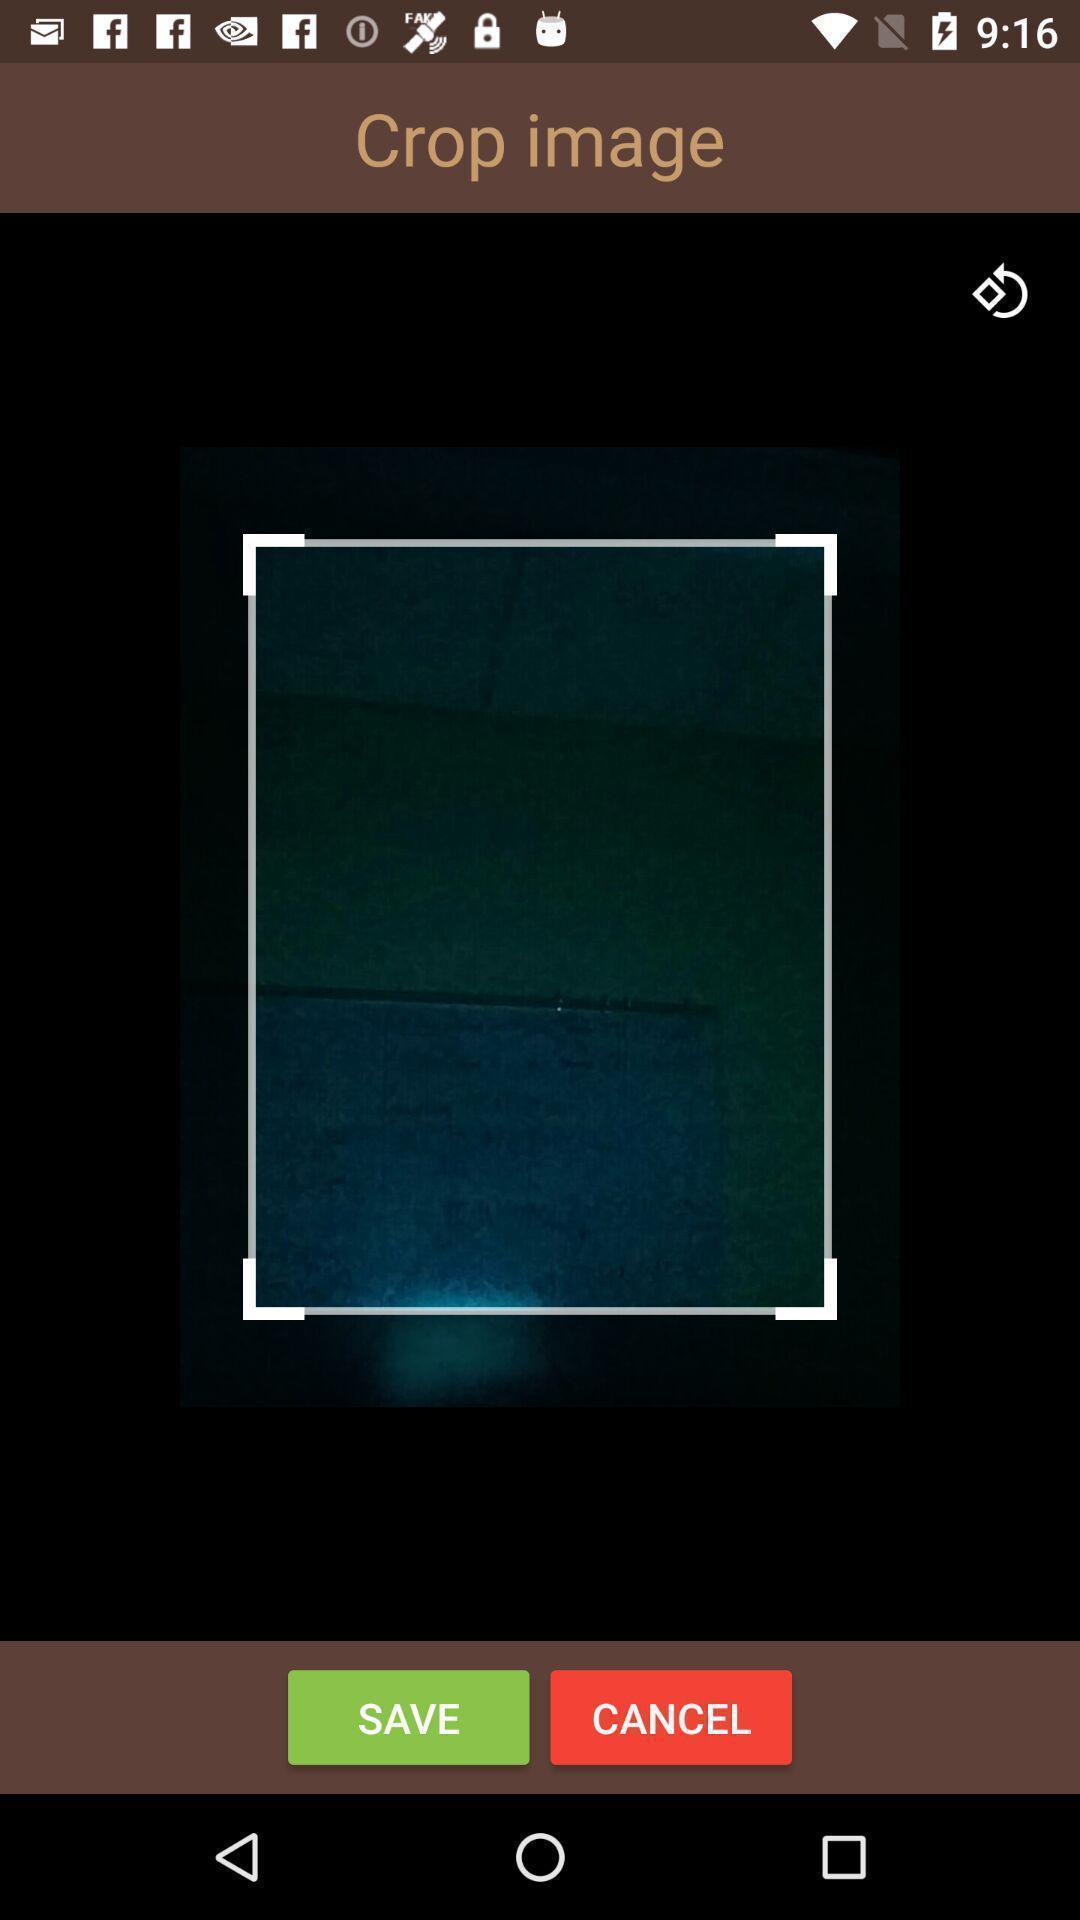Give me a summary of this screen capture. Screen showing crop option. 